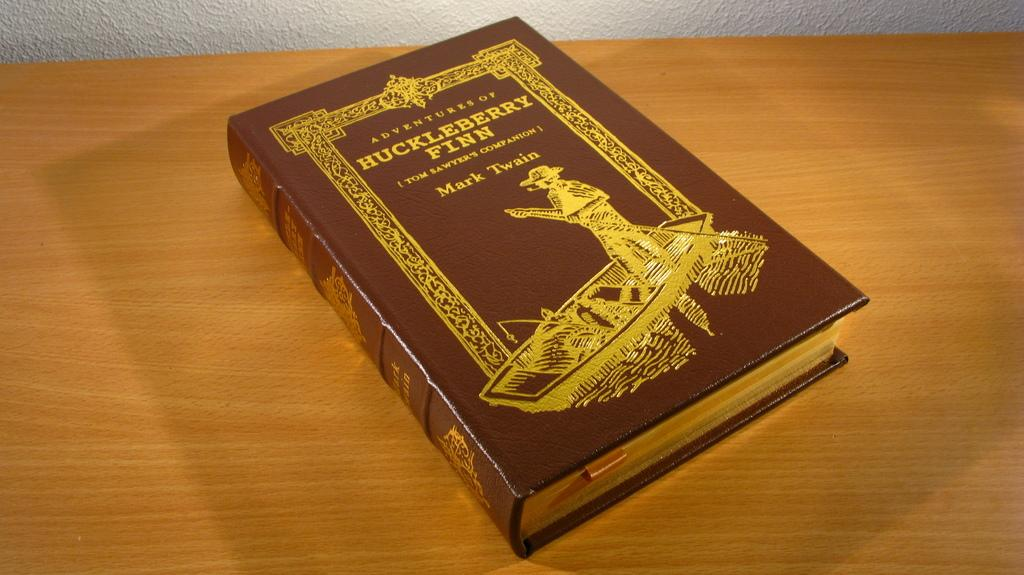<image>
Summarize the visual content of the image. An ornate volume of Huck Fin sits on a wooden surface. 